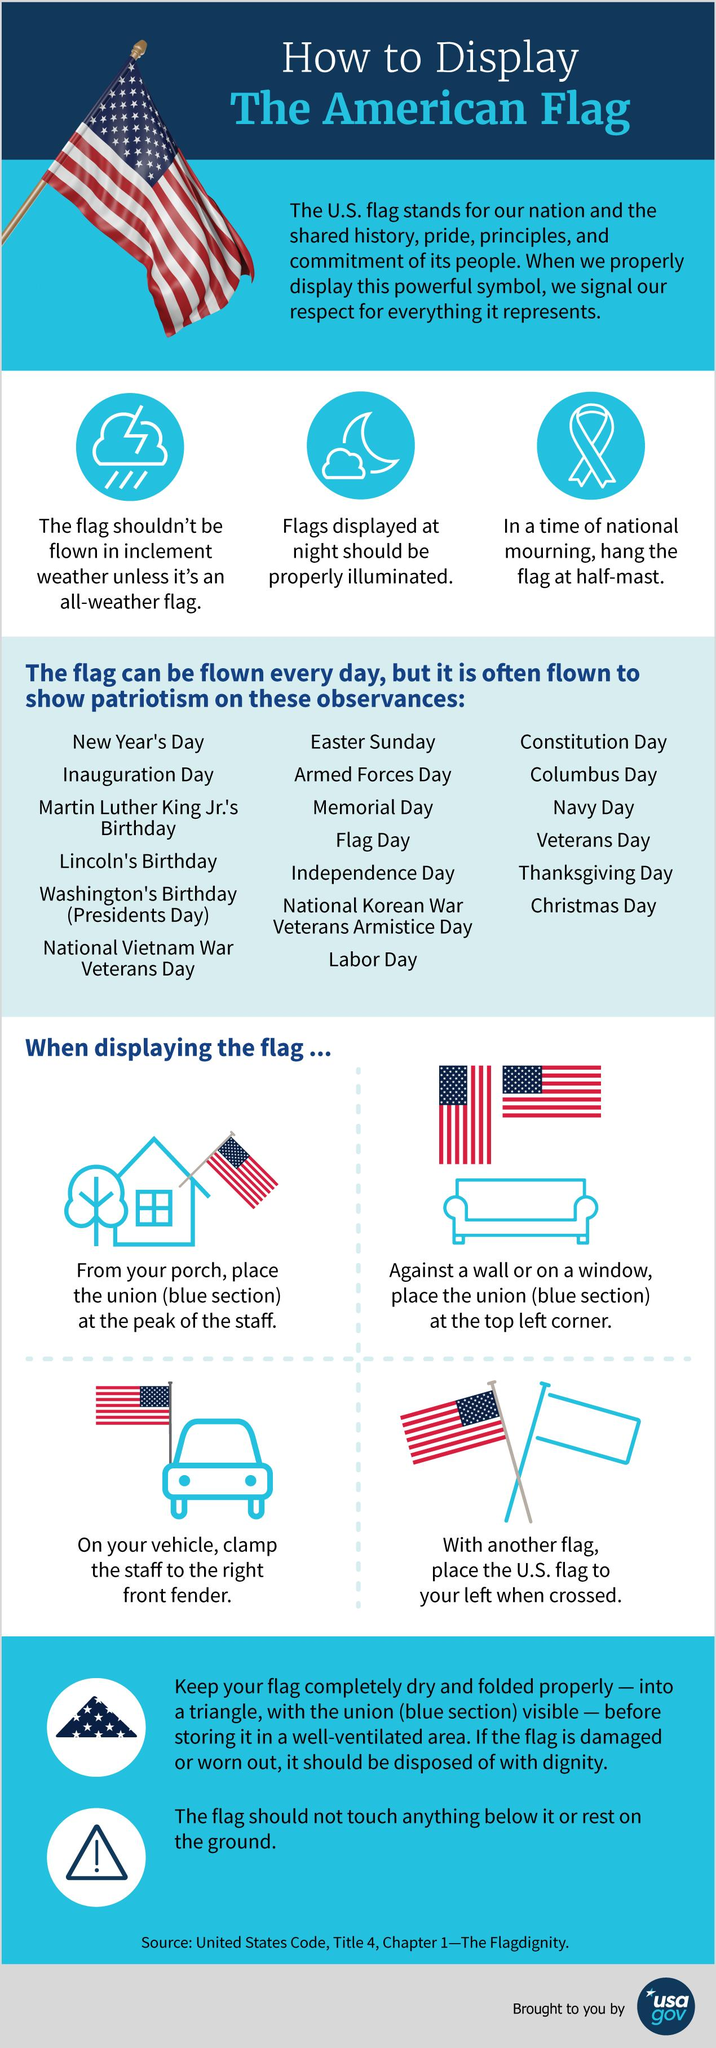Identify some key points in this picture. The flag should not touch anything below it or rest on the ground in order to comply with the rules of display. The flag should be displayed properly illuminated at night if the flag is displayed. When should the flag be at half-mast in a time of national mourning? The flag is often flown to show patriotism on 19 observances. The flag should be displayed with the union (blue section) positioned at the top left corner against a wall or on a window, with the union facing the audience. 